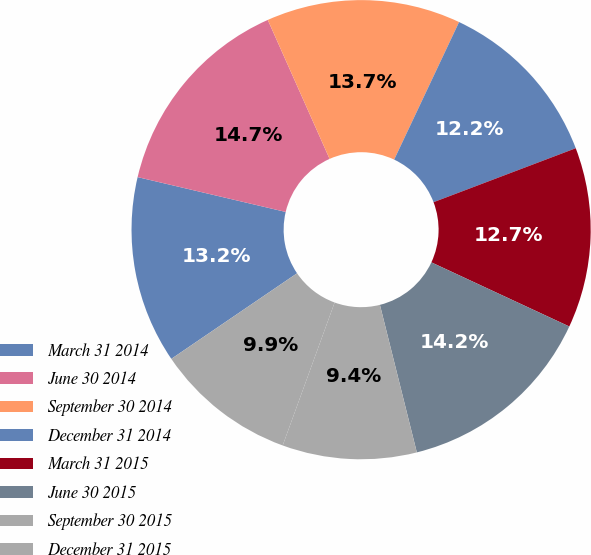<chart> <loc_0><loc_0><loc_500><loc_500><pie_chart><fcel>March 31 2014<fcel>June 30 2014<fcel>September 30 2014<fcel>December 31 2014<fcel>March 31 2015<fcel>June 30 2015<fcel>September 30 2015<fcel>December 31 2015<nl><fcel>13.19%<fcel>14.66%<fcel>13.68%<fcel>12.21%<fcel>12.7%<fcel>14.17%<fcel>9.45%<fcel>9.94%<nl></chart> 